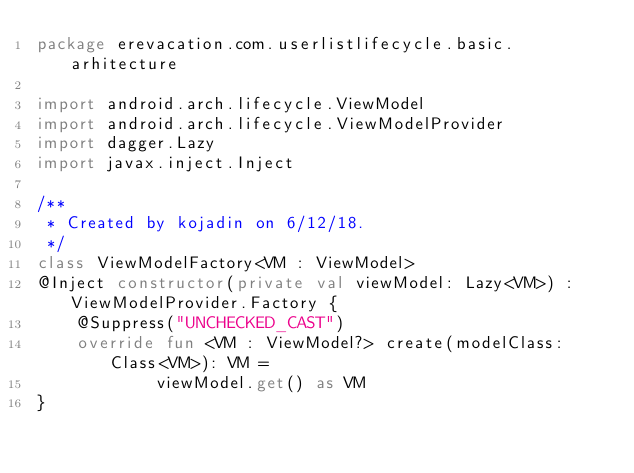Convert code to text. <code><loc_0><loc_0><loc_500><loc_500><_Kotlin_>package erevacation.com.userlistlifecycle.basic.arhitecture

import android.arch.lifecycle.ViewModel
import android.arch.lifecycle.ViewModelProvider
import dagger.Lazy
import javax.inject.Inject

/**
 * Created by kojadin on 6/12/18.
 */
class ViewModelFactory<VM : ViewModel>
@Inject constructor(private val viewModel: Lazy<VM>) : ViewModelProvider.Factory {
    @Suppress("UNCHECKED_CAST")
    override fun <VM : ViewModel?> create(modelClass: Class<VM>): VM =
            viewModel.get() as VM
}</code> 